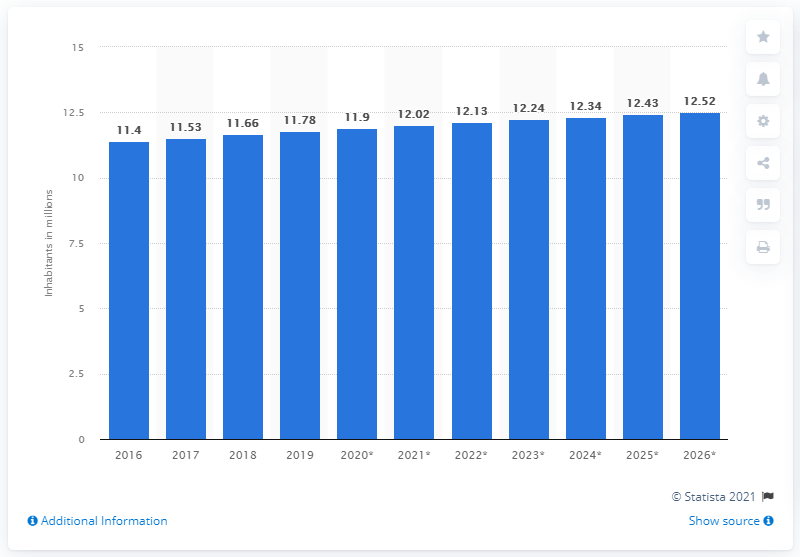Indicate a few pertinent items in this graphic. In the year 2016, it was estimated that the population of Tunisia was approximately 11.78 million. In 2019, the population of Tunisia was estimated to be 11.78 million. 